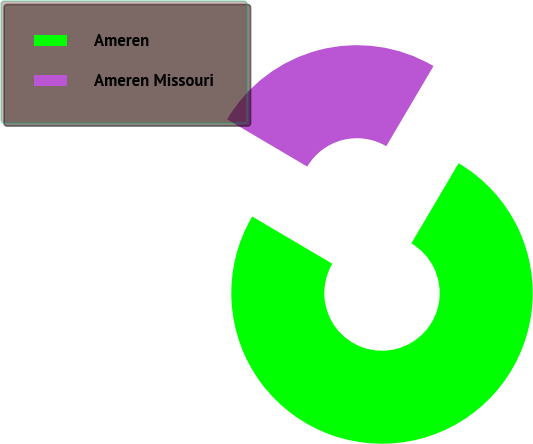Convert chart to OTSL. <chart><loc_0><loc_0><loc_500><loc_500><pie_chart><fcel>Ameren<fcel>Ameren Missouri<nl><fcel>75.0%<fcel>25.0%<nl></chart> 